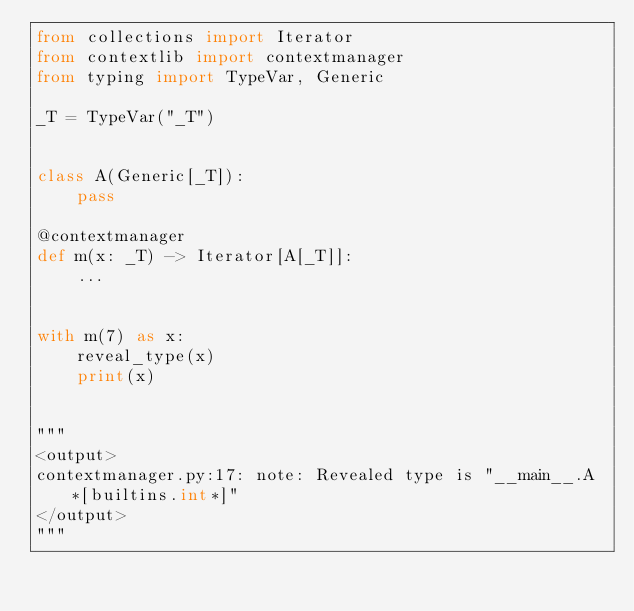Convert code to text. <code><loc_0><loc_0><loc_500><loc_500><_Python_>from collections import Iterator
from contextlib import contextmanager
from typing import TypeVar, Generic

_T = TypeVar("_T")


class A(Generic[_T]):
    pass

@contextmanager
def m(x: _T) -> Iterator[A[_T]]:
    ...


with m(7) as x:
    reveal_type(x)
    print(x)


"""
<output>
contextmanager.py:17: note: Revealed type is "__main__.A*[builtins.int*]"
</output>
"""
</code> 